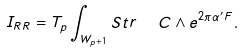Convert formula to latex. <formula><loc_0><loc_0><loc_500><loc_500>I _ { R R } = T _ { p } \int _ { W _ { p + 1 } } S t r \ \ C \wedge e ^ { 2 \pi \alpha ^ { \prime } F } .</formula> 